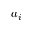Convert formula to latex. <formula><loc_0><loc_0><loc_500><loc_500>a _ { i }</formula> 